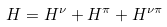Convert formula to latex. <formula><loc_0><loc_0><loc_500><loc_500>H = H ^ { \nu } + H ^ { \pi } + H ^ { \nu \pi }</formula> 